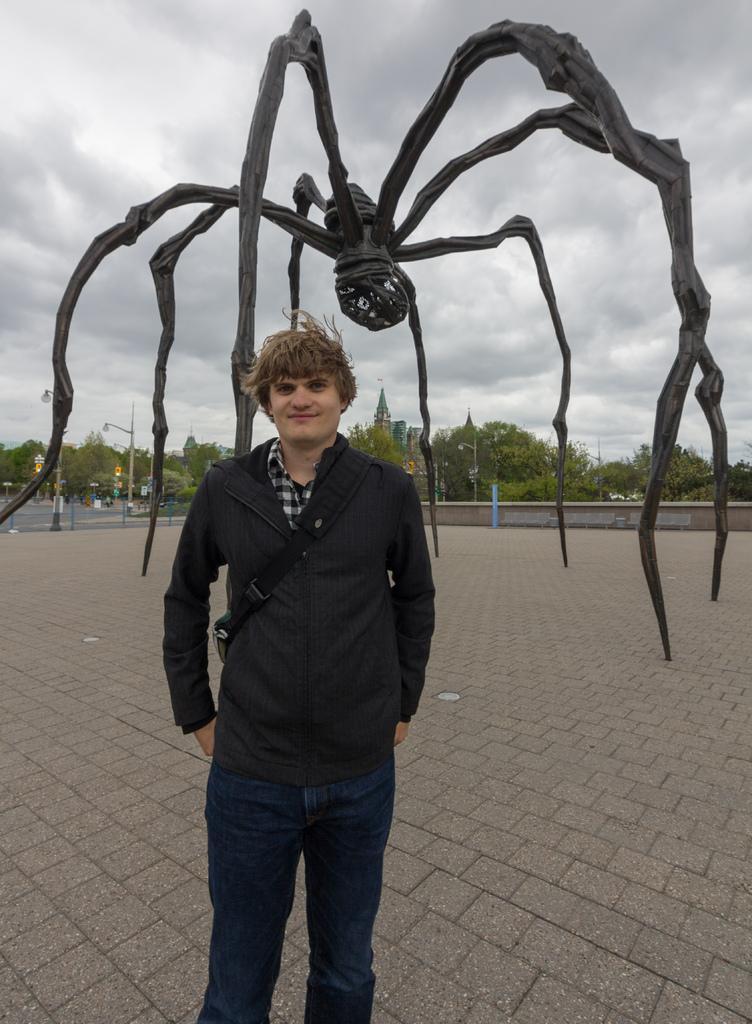Can you describe this image briefly? This image is taken outdoors. At the bottom of the image there is a floor. At the top of the image there is a sky with clouds. In the middle of the image a man is standing on the floor and there is a big artificial spider on the floor. In the background there are many trees, a few buildings and poles with street lights. 